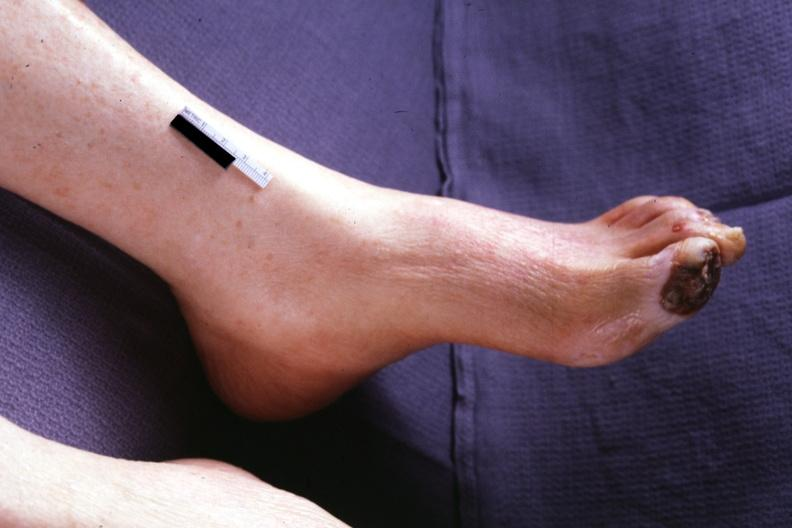what is present?
Answer the question using a single word or phrase. Foot 